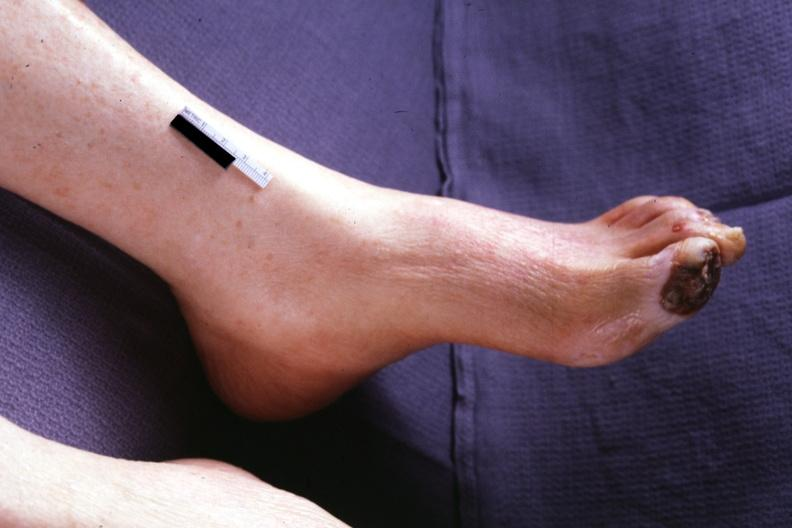what is present?
Answer the question using a single word or phrase. Foot 